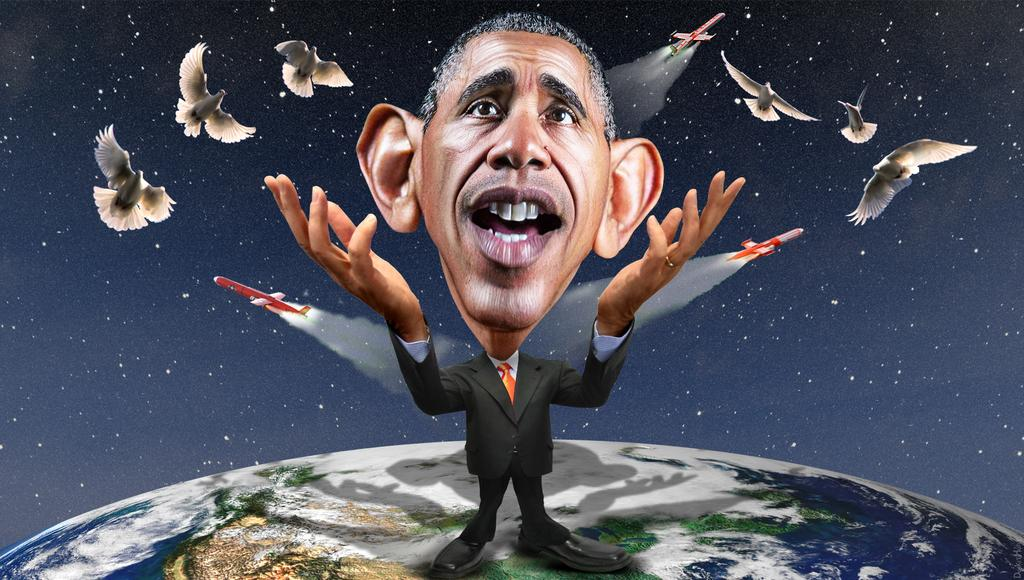What is the nature of the image? The image appears to be edited. What is the man in the image doing? The man is standing on the earth in the image. What is happening in the sky in the image? There are birds flying and aircrafts flying in the sky in the image. What celestial objects can be seen in the image? Stars are visible in the image. What type of shoes is the man wearing in the image? There is no information about the man's shoes in the image, as the focus is on his standing position and the surrounding elements. 